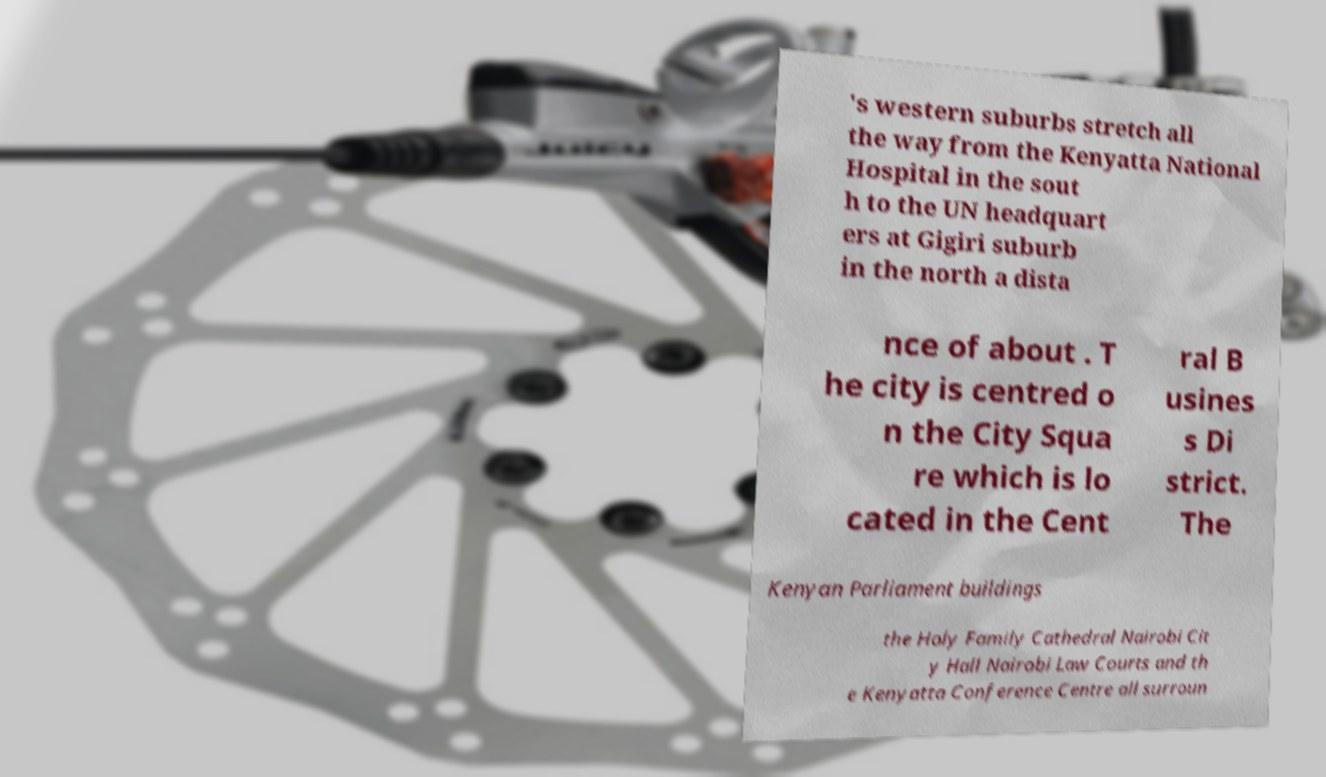Can you read and provide the text displayed in the image?This photo seems to have some interesting text. Can you extract and type it out for me? 's western suburbs stretch all the way from the Kenyatta National Hospital in the sout h to the UN headquart ers at Gigiri suburb in the north a dista nce of about . T he city is centred o n the City Squa re which is lo cated in the Cent ral B usines s Di strict. The Kenyan Parliament buildings the Holy Family Cathedral Nairobi Cit y Hall Nairobi Law Courts and th e Kenyatta Conference Centre all surroun 